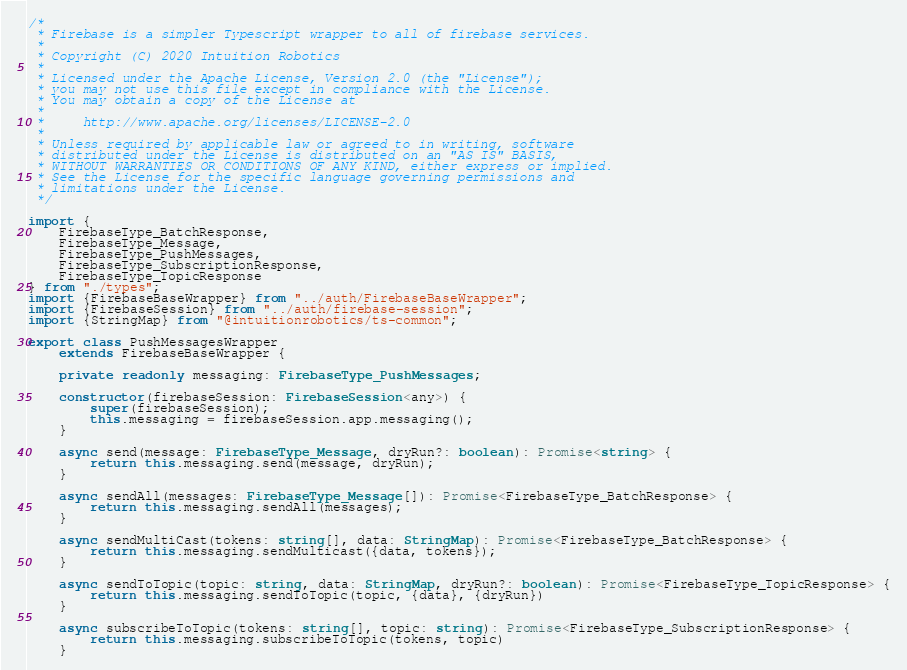Convert code to text. <code><loc_0><loc_0><loc_500><loc_500><_TypeScript_>/*
 * Firebase is a simpler Typescript wrapper to all of firebase services.
 *
 * Copyright (C) 2020 Intuition Robotics
 *
 * Licensed under the Apache License, Version 2.0 (the "License");
 * you may not use this file except in compliance with the License.
 * You may obtain a copy of the License at
 *
 *     http://www.apache.org/licenses/LICENSE-2.0
 *
 * Unless required by applicable law or agreed to in writing, software
 * distributed under the License is distributed on an "AS IS" BASIS,
 * WITHOUT WARRANTIES OR CONDITIONS OF ANY KIND, either express or implied.
 * See the License for the specific language governing permissions and
 * limitations under the License.
 */

import {
	FirebaseType_BatchResponse,
	FirebaseType_Message,
	FirebaseType_PushMessages,
	FirebaseType_SubscriptionResponse,
	FirebaseType_TopicResponse
} from "./types";
import {FirebaseBaseWrapper} from "../auth/FirebaseBaseWrapper";
import {FirebaseSession} from "../auth/firebase-session";
import {StringMap} from "@intuitionrobotics/ts-common";

export class PushMessagesWrapper
	extends FirebaseBaseWrapper {

	private readonly messaging: FirebaseType_PushMessages;

	constructor(firebaseSession: FirebaseSession<any>) {
		super(firebaseSession);
		this.messaging = firebaseSession.app.messaging();
	}

	async send(message: FirebaseType_Message, dryRun?: boolean): Promise<string> {
		return this.messaging.send(message, dryRun);
	}

	async sendAll(messages: FirebaseType_Message[]): Promise<FirebaseType_BatchResponse> {
		return this.messaging.sendAll(messages);
	}

	async sendMultiCast(tokens: string[], data: StringMap): Promise<FirebaseType_BatchResponse> {
		return this.messaging.sendMulticast({data, tokens});
	}

	async sendToTopic(topic: string, data: StringMap, dryRun?: boolean): Promise<FirebaseType_TopicResponse> {
		return this.messaging.sendToTopic(topic, {data}, {dryRun})
	}

	async subscribeToTopic(tokens: string[], topic: string): Promise<FirebaseType_SubscriptionResponse> {
		return this.messaging.subscribeToTopic(tokens, topic)
	}
</code> 